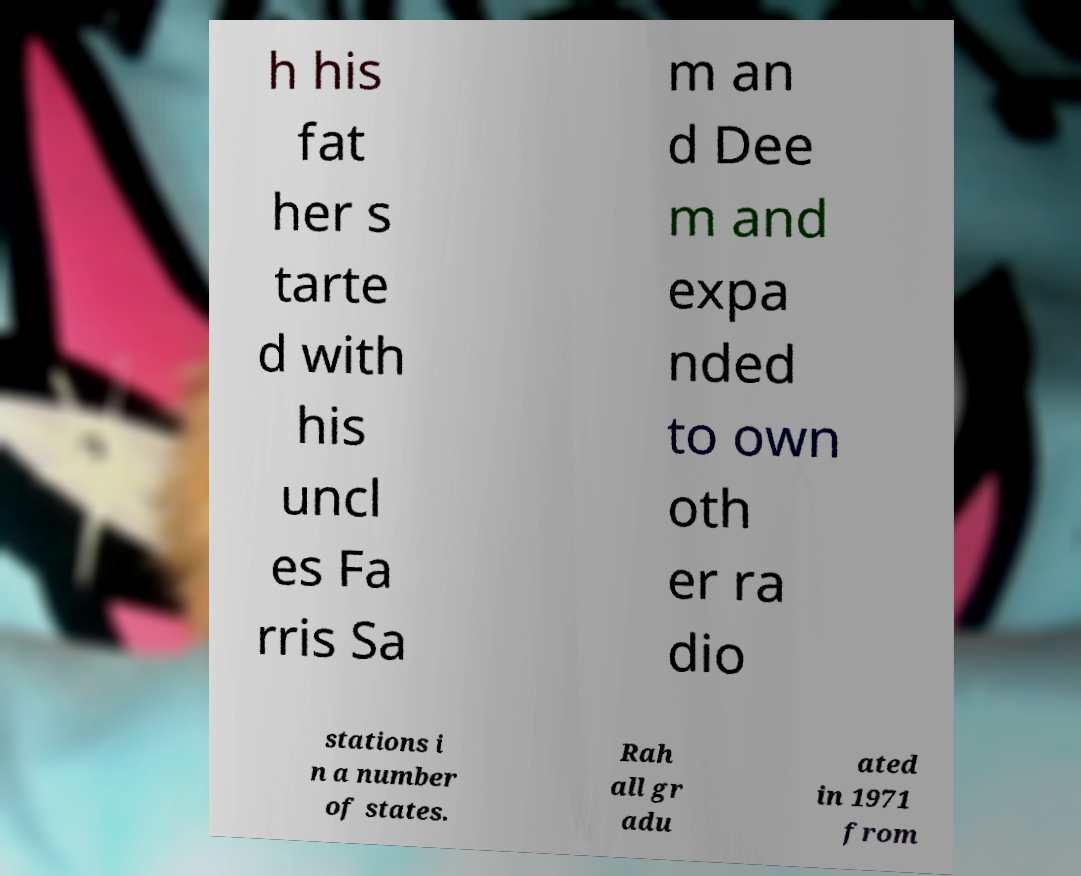For documentation purposes, I need the text within this image transcribed. Could you provide that? h his fat her s tarte d with his uncl es Fa rris Sa m an d Dee m and expa nded to own oth er ra dio stations i n a number of states. Rah all gr adu ated in 1971 from 